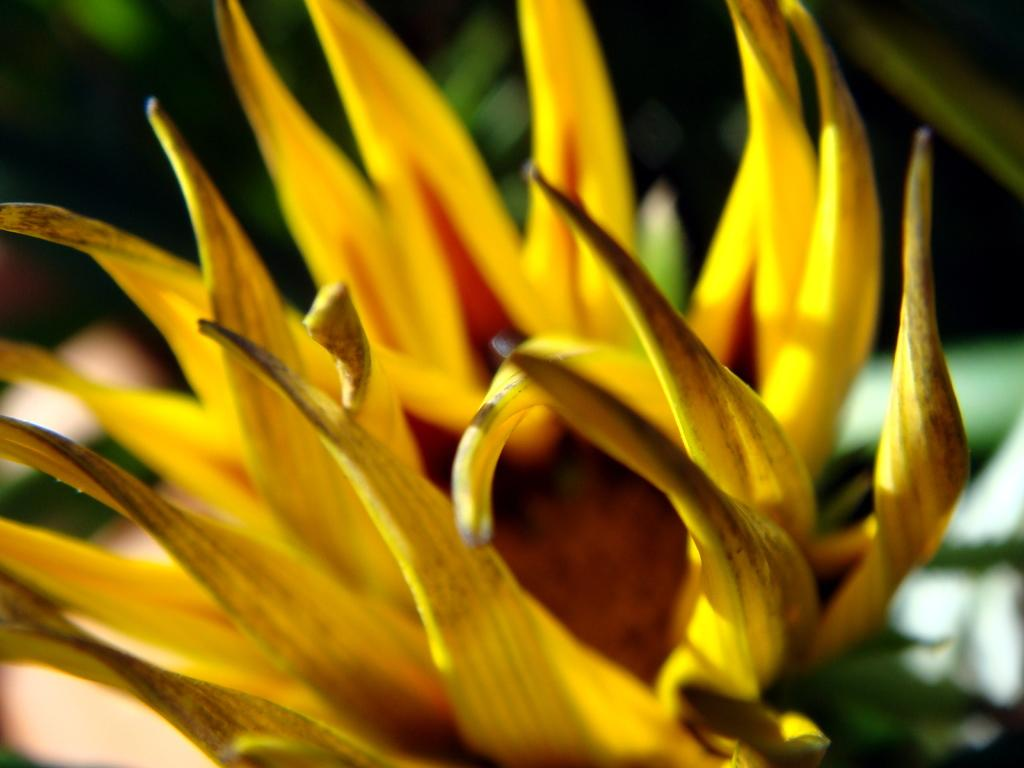What type of flower is present in the image? There is a yellow color flower in the image. How many screws can be seen holding the flower in place in the image? There are no screws present in the image, as the flower is not attached to anything. What type of eggs are visible in the image? There are no eggs present in the image; it only features a yellow color flower. 